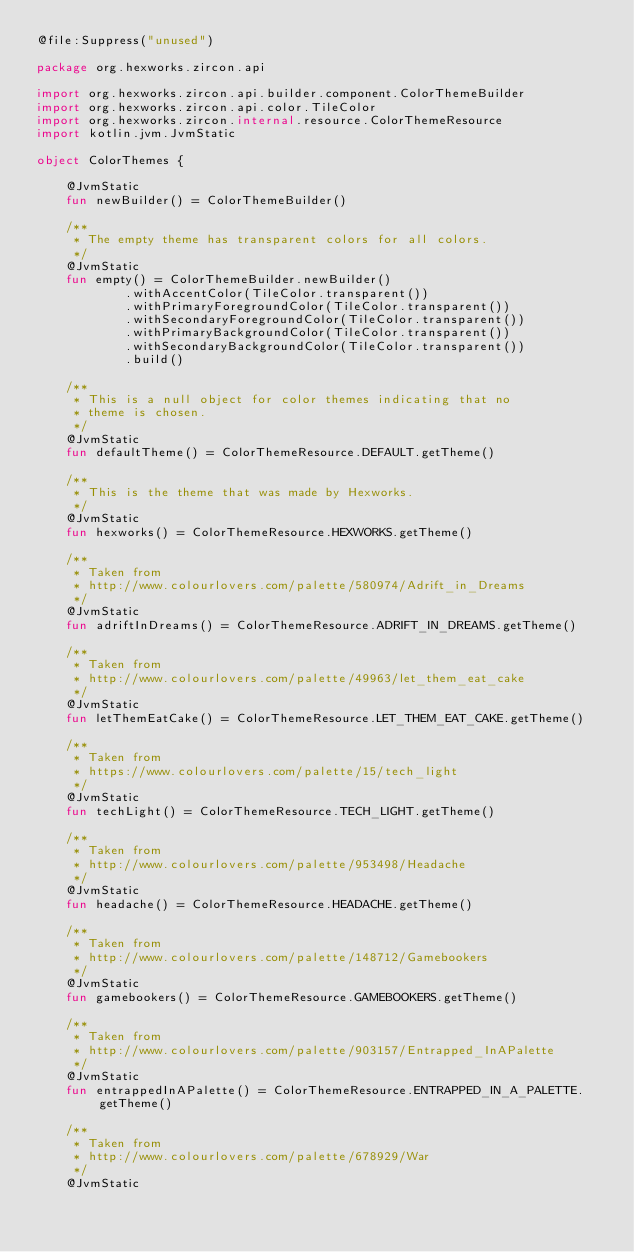<code> <loc_0><loc_0><loc_500><loc_500><_Kotlin_>@file:Suppress("unused")

package org.hexworks.zircon.api

import org.hexworks.zircon.api.builder.component.ColorThemeBuilder
import org.hexworks.zircon.api.color.TileColor
import org.hexworks.zircon.internal.resource.ColorThemeResource
import kotlin.jvm.JvmStatic

object ColorThemes {

    @JvmStatic
    fun newBuilder() = ColorThemeBuilder()

    /**
     * The empty theme has transparent colors for all colors.
     */
    @JvmStatic
    fun empty() = ColorThemeBuilder.newBuilder()
            .withAccentColor(TileColor.transparent())
            .withPrimaryForegroundColor(TileColor.transparent())
            .withSecondaryForegroundColor(TileColor.transparent())
            .withPrimaryBackgroundColor(TileColor.transparent())
            .withSecondaryBackgroundColor(TileColor.transparent())
            .build()

    /**
     * This is a null object for color themes indicating that no
     * theme is chosen.
     */
    @JvmStatic
    fun defaultTheme() = ColorThemeResource.DEFAULT.getTheme()

    /**
     * This is the theme that was made by Hexworks.
     */
    @JvmStatic
    fun hexworks() = ColorThemeResource.HEXWORKS.getTheme()

    /**
     * Taken from
     * http://www.colourlovers.com/palette/580974/Adrift_in_Dreams
     */
    @JvmStatic
    fun adriftInDreams() = ColorThemeResource.ADRIFT_IN_DREAMS.getTheme()

    /**
     * Taken from
     * http://www.colourlovers.com/palette/49963/let_them_eat_cake
     */
    @JvmStatic
    fun letThemEatCake() = ColorThemeResource.LET_THEM_EAT_CAKE.getTheme()

    /**
     * Taken from
     * https://www.colourlovers.com/palette/15/tech_light
     */
    @JvmStatic
    fun techLight() = ColorThemeResource.TECH_LIGHT.getTheme()

    /**
     * Taken from
     * http://www.colourlovers.com/palette/953498/Headache
     */
    @JvmStatic
    fun headache() = ColorThemeResource.HEADACHE.getTheme()

    /**
     * Taken from
     * http://www.colourlovers.com/palette/148712/Gamebookers
     */
    @JvmStatic
    fun gamebookers() = ColorThemeResource.GAMEBOOKERS.getTheme()

    /**
     * Taken from
     * http://www.colourlovers.com/palette/903157/Entrapped_InAPalette
     */
    @JvmStatic
    fun entrappedInAPalette() = ColorThemeResource.ENTRAPPED_IN_A_PALETTE.getTheme()

    /**
     * Taken from
     * http://www.colourlovers.com/palette/678929/War
     */
    @JvmStatic</code> 